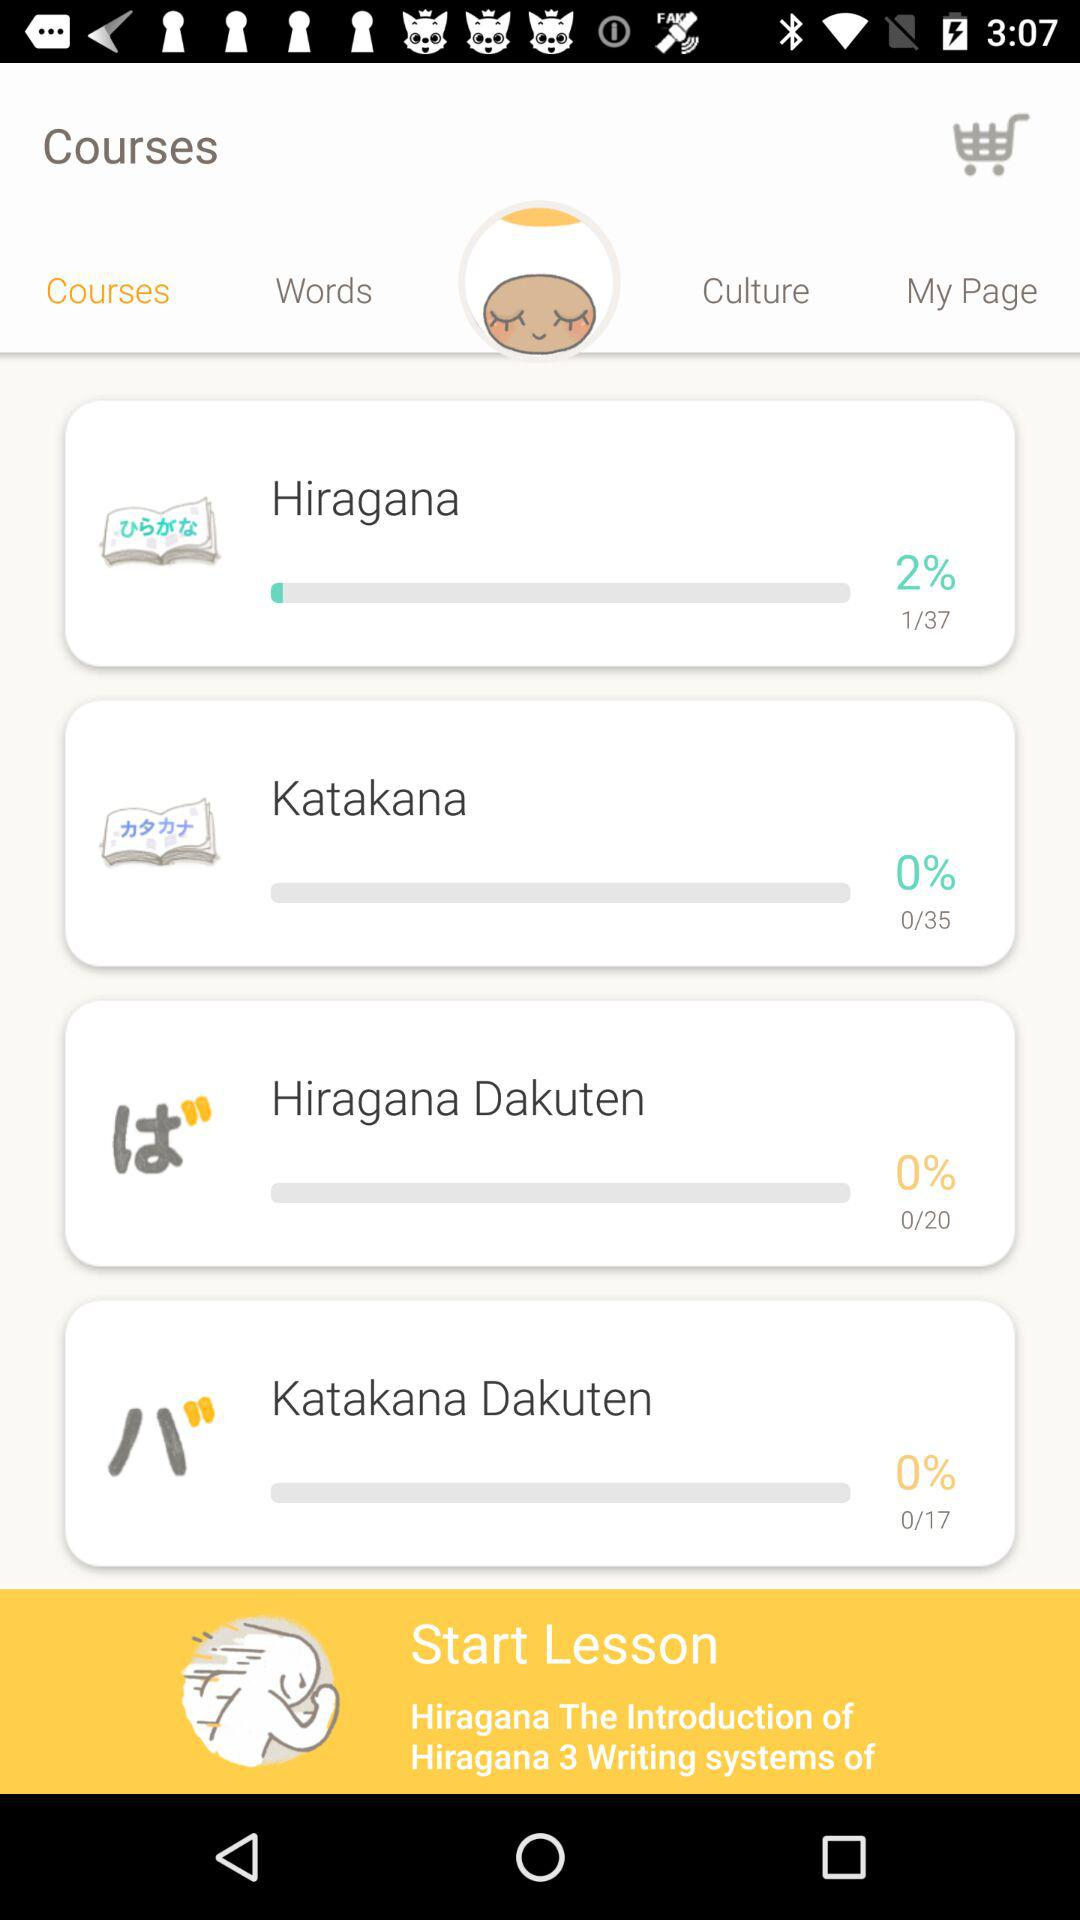Which lesson has a higher percentage completed, Hiragana or Katakana?
Answer the question using a single word or phrase. Hiragana 